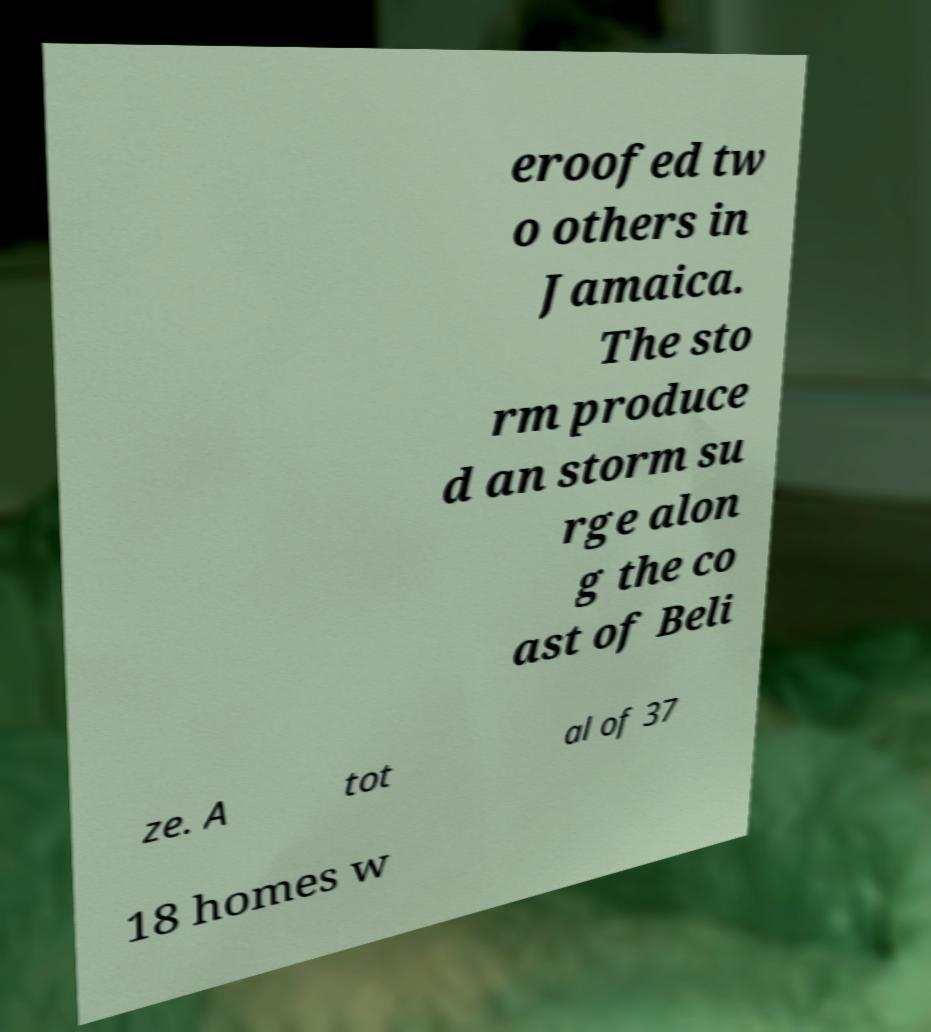Can you read and provide the text displayed in the image?This photo seems to have some interesting text. Can you extract and type it out for me? eroofed tw o others in Jamaica. The sto rm produce d an storm su rge alon g the co ast of Beli ze. A tot al of 37 18 homes w 